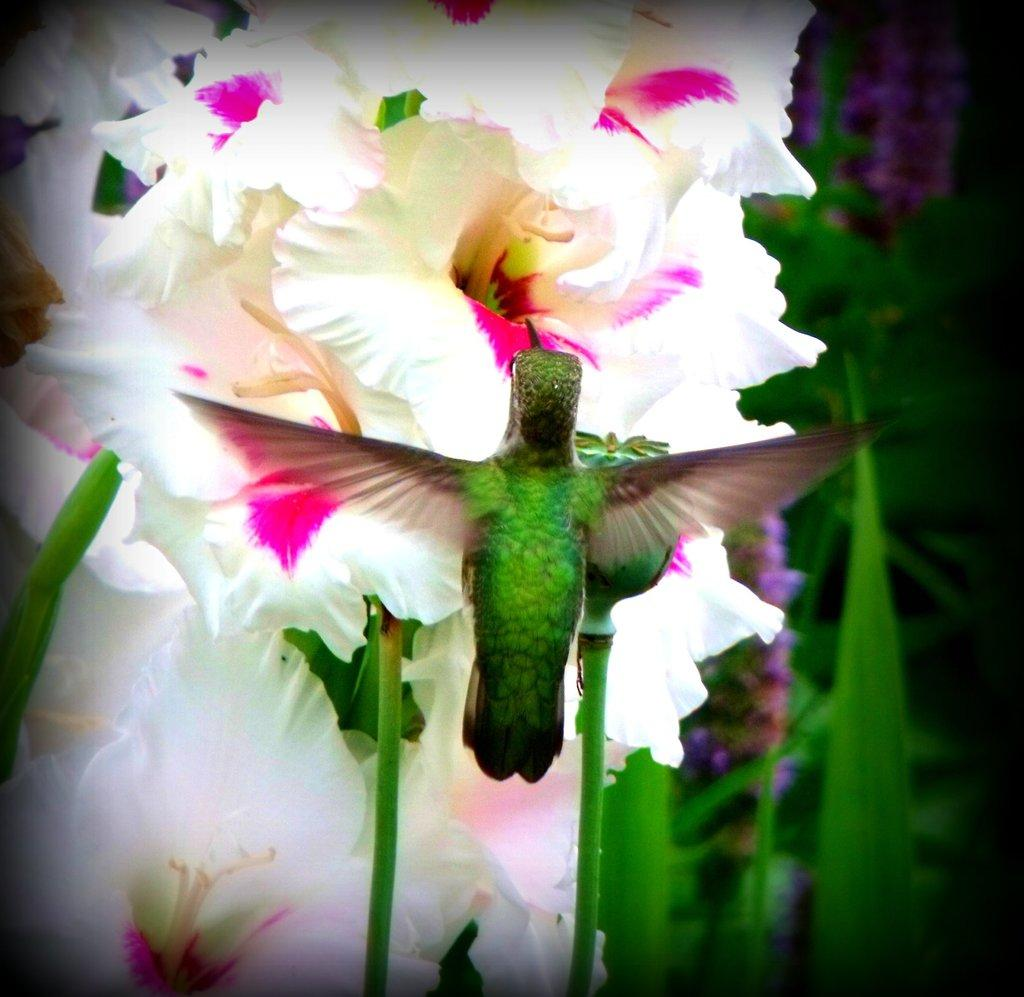What is the main subject in the center of the image? There are plants and flowers in the center of the image. What colors are the plants and flowers? The plants and flowers are in white and pink colors. Is there any other living creature present in the image? Yes, there is a bird on the flowers. What color is the bird? The bird is in green color. How many boys are holding the basket of flowers in the image? There is no basket of flowers or boys present in the image. 